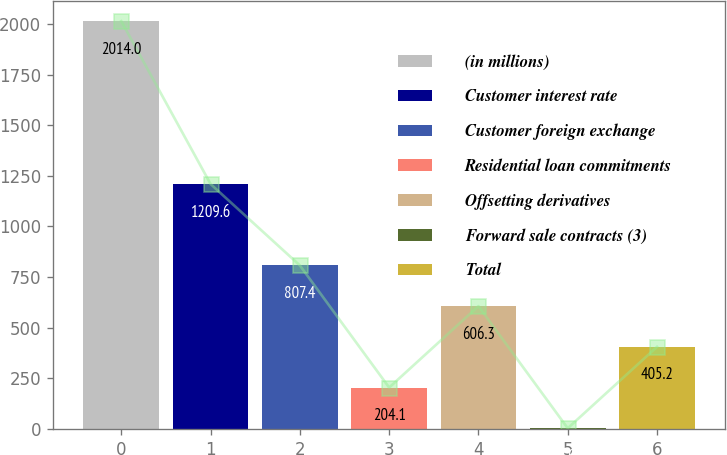Convert chart. <chart><loc_0><loc_0><loc_500><loc_500><bar_chart><fcel>(in millions)<fcel>Customer interest rate<fcel>Customer foreign exchange<fcel>Residential loan commitments<fcel>Offsetting derivatives<fcel>Forward sale contracts (3)<fcel>Total<nl><fcel>2014<fcel>1209.6<fcel>807.4<fcel>204.1<fcel>606.3<fcel>3<fcel>405.2<nl></chart> 